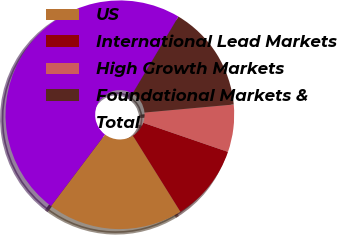<chart> <loc_0><loc_0><loc_500><loc_500><pie_chart><fcel>US<fcel>International Lead Markets<fcel>High Growth Markets<fcel>Foundational Markets &<fcel>Total<nl><fcel>19.17%<fcel>10.85%<fcel>6.7%<fcel>15.01%<fcel>48.27%<nl></chart> 